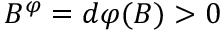Convert formula to latex. <formula><loc_0><loc_0><loc_500><loc_500>B ^ { \varphi } = d \varphi ( B ) > 0</formula> 